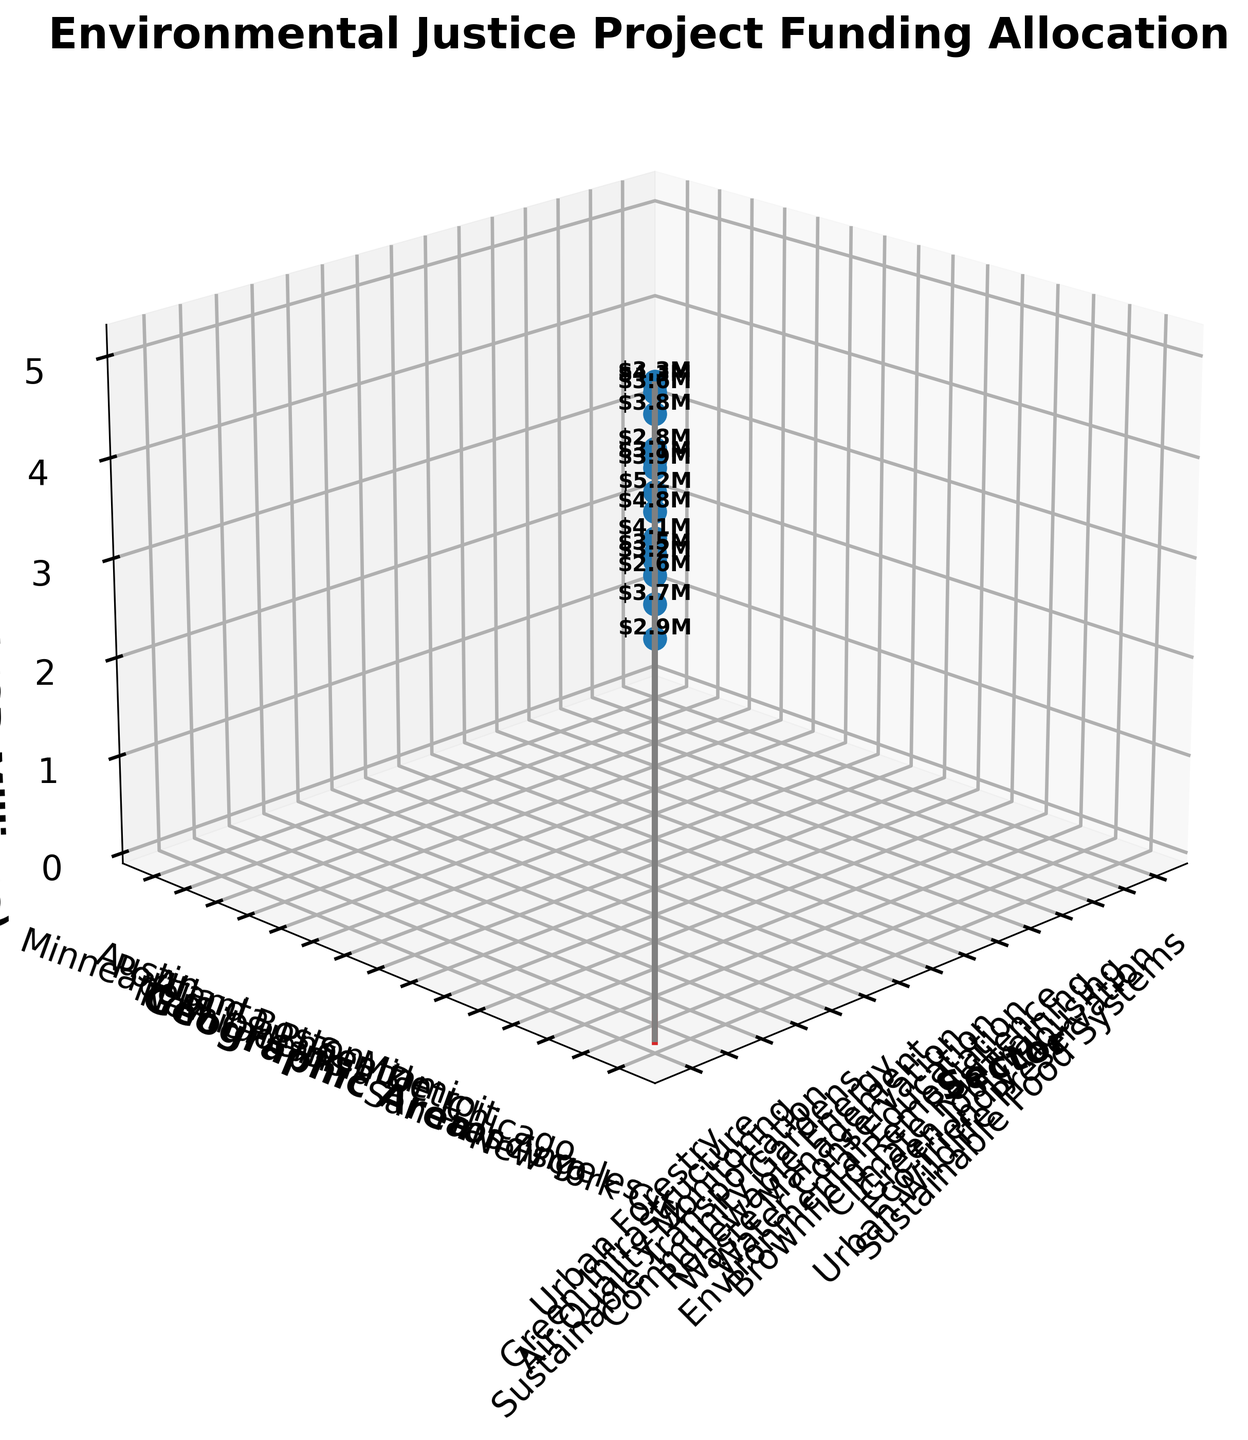What is the title of the 3D stem plot? The title is written prominently at the top of the plot, providing an overview of the figure.
Answer: Environmental Justice Project Funding Allocation Which sector in New York City received funding and how much? Look at the stem that corresponds to New York City on the geographical area axis and read the sector label at the base and the funding amount next to the stem.
Answer: Urban Forestry, $5.2M What is the funding allocation for Renewable Energy in Miami? Locate the stem related to Miami on the geographical area axis, then read the sector label and adjacent funding amount.
Answer: $3.5M How many sectors received funding? Count the number of unique sectors labeled on the sector axis.
Answer: 15 What is the combined funding amount for Chicago and Seattle? Find and sum the funding amounts listed next to the stems for Chicago and Seattle.
Answer: $3.7M + $3.2M = $6.9M Which geographic area received the highest funding and for which sector? Identify the tallest stem in the plot and read the labels for the corresponding sector and geographic area.
Answer: New York City, Urban Forestry Compare the funding amounts for Green Infrastructure in Los Angeles and Air Quality Monitoring in Chicago. Which one received more and by how much? Find the stems for these sectors in Los Angeles and Chicago, then subtract the smaller amount from the larger.
Answer: Green Infrastructure received $4.8M, Air Quality Monitoring received $3.7M, so $4.8M - $3.7M = $1.1M more What is the average funding amount provided to sectors in Detroit and San Francisco? Add the funding amounts provided to sectors in Detroit and San Francisco and then divide by 2.
Answer: ($2.9M + $4.1M) / 2 = $3.5M What is the funding allocation for Sustainable Transportation in San Francisco compared to Eco-friendly Housing in Portland? Locate the respective stems for each sector and compare their funding amounts.
Answer: Sustainable Transportation in San Francisco: $4.1M, Eco-friendly Housing in Portland: $3.6M. San Francisco received more by $0.5M In which geographic area is the funding closest to $3.2M and which sector is it for? Identify the geographical area matching or closest to $3.2M funding by inspecting the height of the stems and checking the labels.
Answer: Seattle, Waste Management 